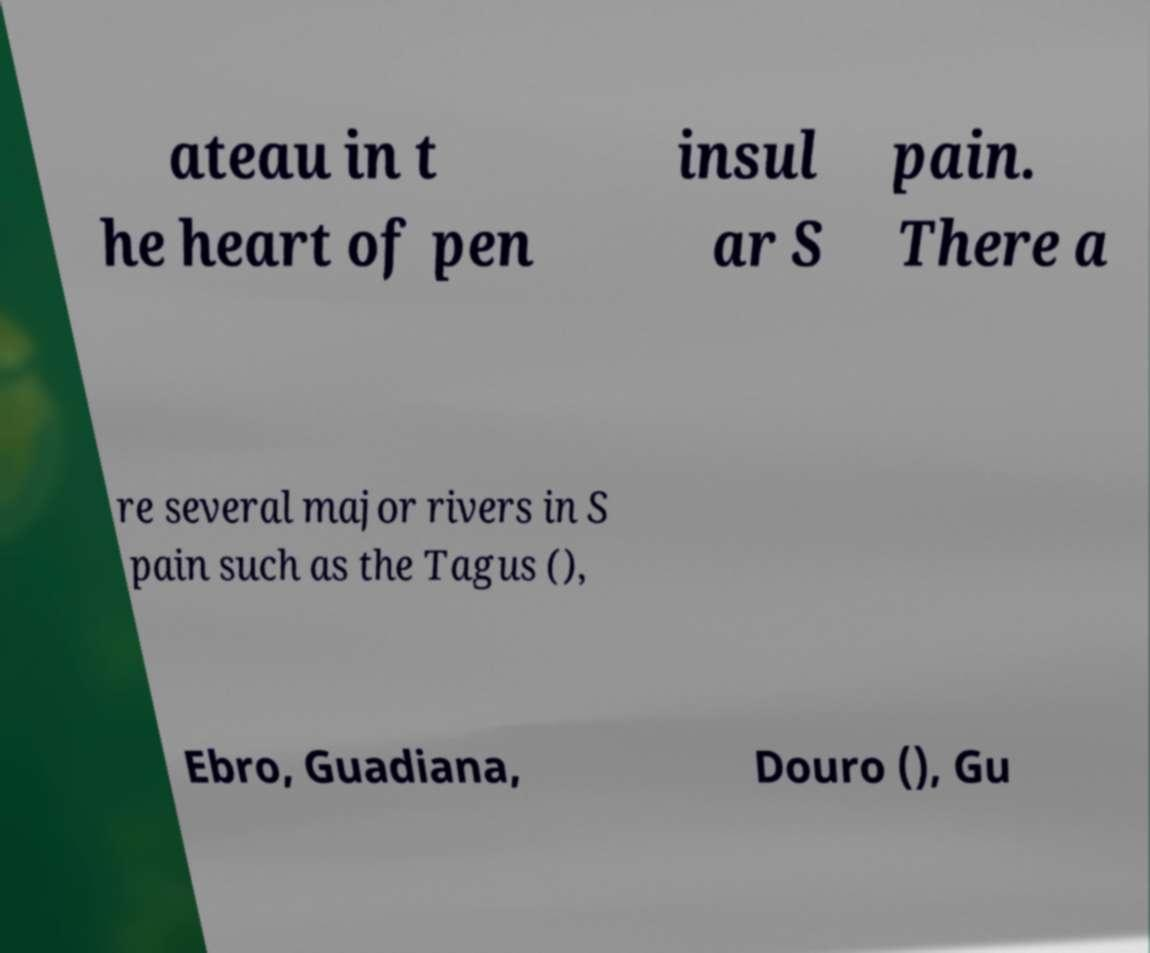For documentation purposes, I need the text within this image transcribed. Could you provide that? ateau in t he heart of pen insul ar S pain. There a re several major rivers in S pain such as the Tagus (), Ebro, Guadiana, Douro (), Gu 